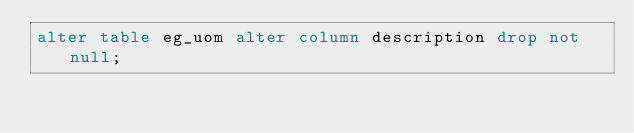Convert code to text. <code><loc_0><loc_0><loc_500><loc_500><_SQL_>alter table eg_uom alter column description drop not null;
</code> 